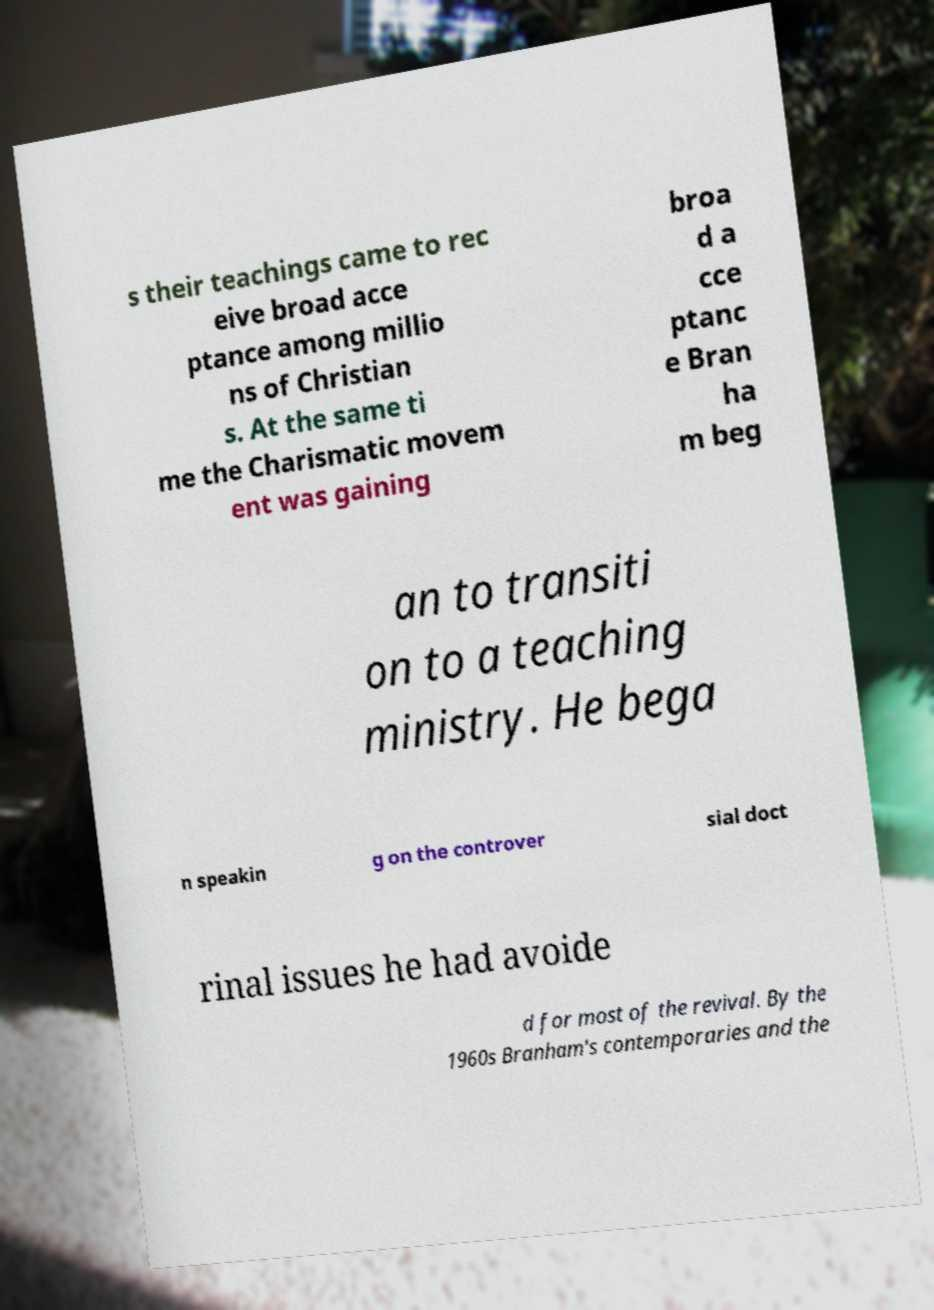There's text embedded in this image that I need extracted. Can you transcribe it verbatim? s their teachings came to rec eive broad acce ptance among millio ns of Christian s. At the same ti me the Charismatic movem ent was gaining broa d a cce ptanc e Bran ha m beg an to transiti on to a teaching ministry. He bega n speakin g on the controver sial doct rinal issues he had avoide d for most of the revival. By the 1960s Branham's contemporaries and the 